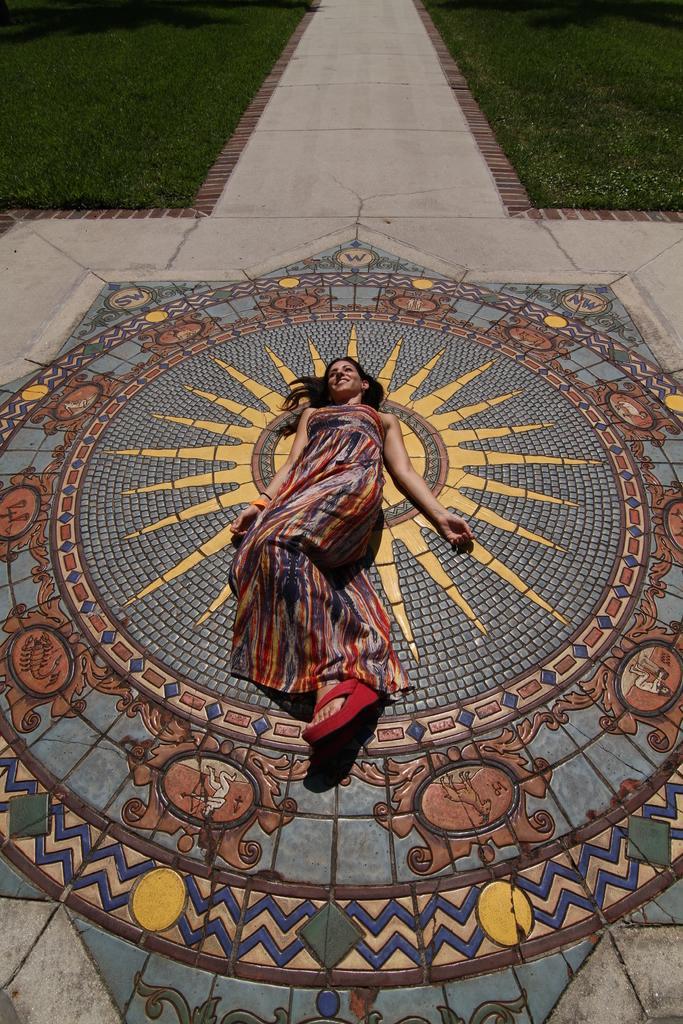How would you summarize this image in a sentence or two? In this picture we can see a woman on the floor and smiling. In the background we can see the path and the grass. 